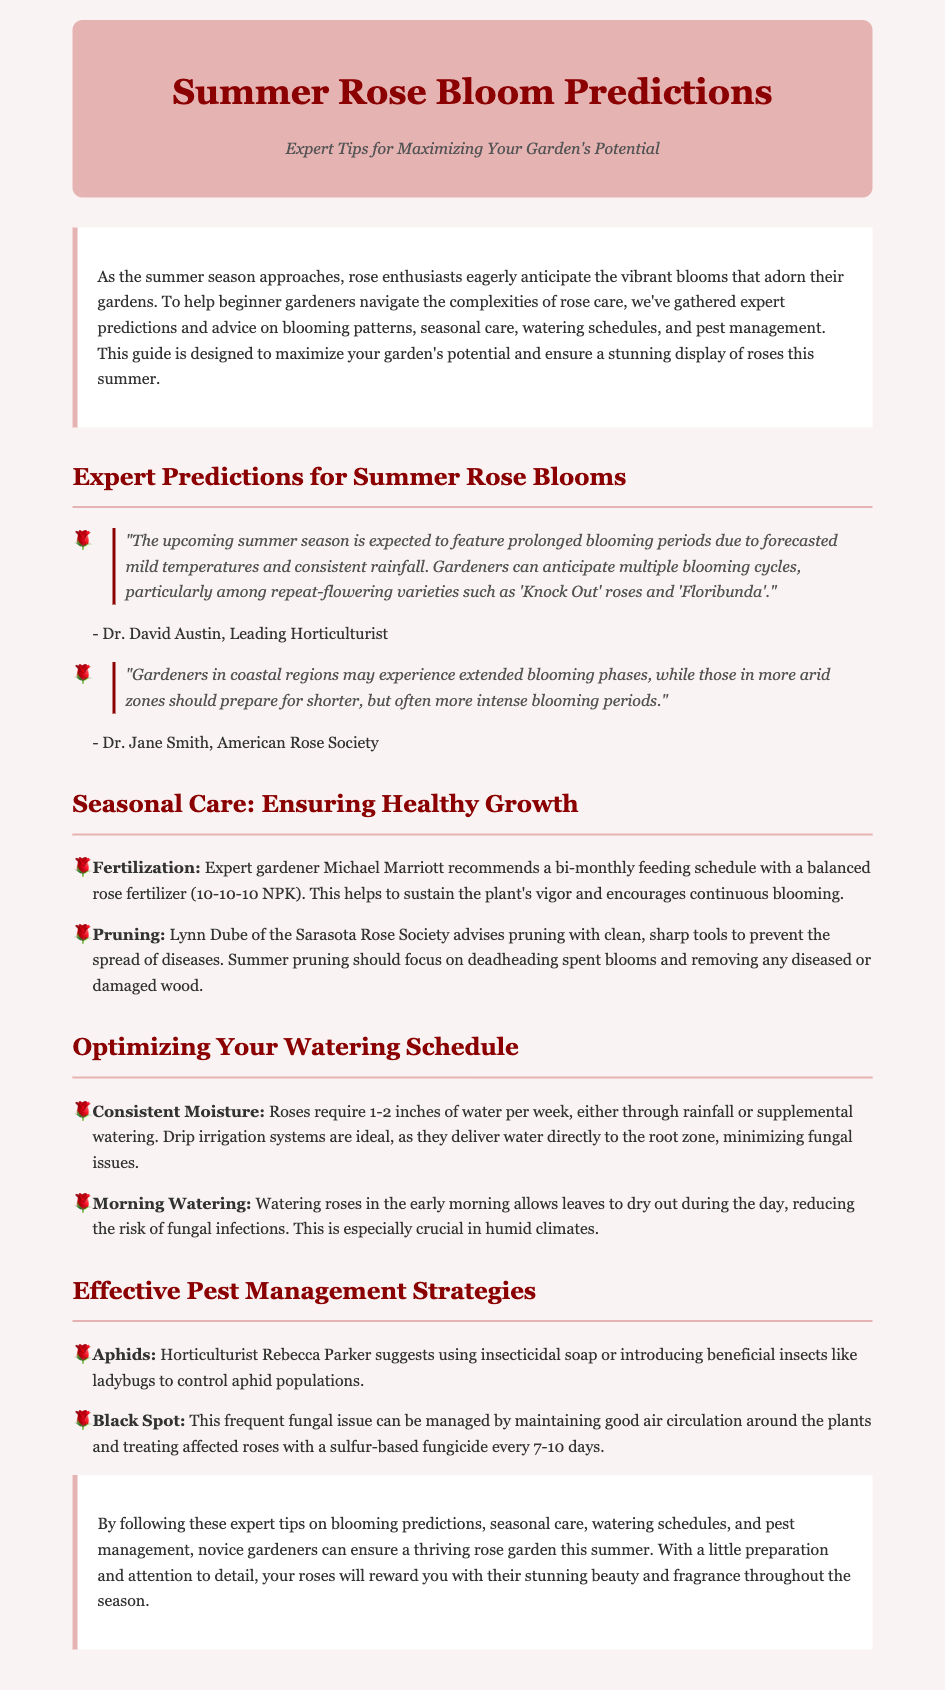what is the title of the press release? The title is stated clearly at the beginning of the document.
Answer: Summer Rose Bloom Predictions who is the leading horticulturist quoted in the document? The document mentions Dr. David Austin as a leading horticulturist.
Answer: Dr. David Austin what is the recommended fertilization schedule for roses? The document provides specific advice on fertilization in the seasonal care section.
Answer: bi-monthly how much water do roses require weekly? The watering schedule section specifies the required amount of water for roses.
Answer: 1-2 inches which pest management strategy is suggested for controlling aphids? The document lists specific pest management strategies in the relevant section.
Answer: insecticidal soap what is a key focus during summer pruning? The pruning advice includes details on what to prioritize during summer.
Answer: deadheading spent blooms which type of fungicide should be used for black spot? The document provides specific treatment advice for managing black spot.
Answer: sulfur-based fungicide what months does the summer season typically cover in the document? While not explicitly stated, the context of the document implies summer months.
Answer: June to September 